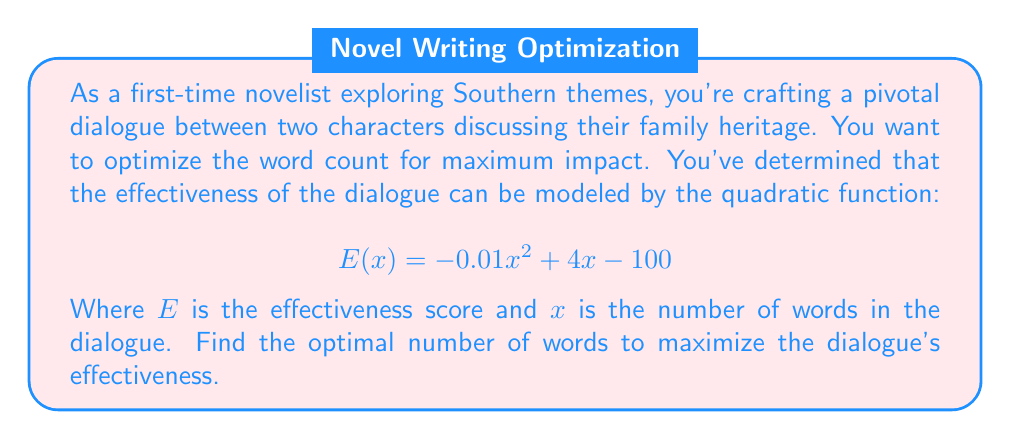Solve this math problem. To find the optimal number of words that maximizes the dialogue's effectiveness, we need to find the vertex of the parabola described by the quadratic function. The vertex represents the maximum point of the parabola since the coefficient of $x^2$ is negative (indicating the parabola opens downward).

For a quadratic function in the form $f(x) = ax^2 + bx + c$, the x-coordinate of the vertex is given by $x = -\frac{b}{2a}$.

In our case:
$a = -0.01$
$b = 4$
$c = -100$

Let's calculate the x-coordinate of the vertex:

$$x = -\frac{b}{2a} = -\frac{4}{2(-0.01)} = -\frac{4}{-0.02} = 200$$

To verify this is indeed a maximum, we can calculate the y-coordinate of the vertex:

$$E(200) = -0.01(200)^2 + 4(200) - 100$$
$$= -400 + 800 - 100 = 300$$

This gives us the maximum effectiveness score of 300 at 200 words.
Answer: The optimal number of words for the dialogue is 200, which will yield the maximum effectiveness score of 300. 